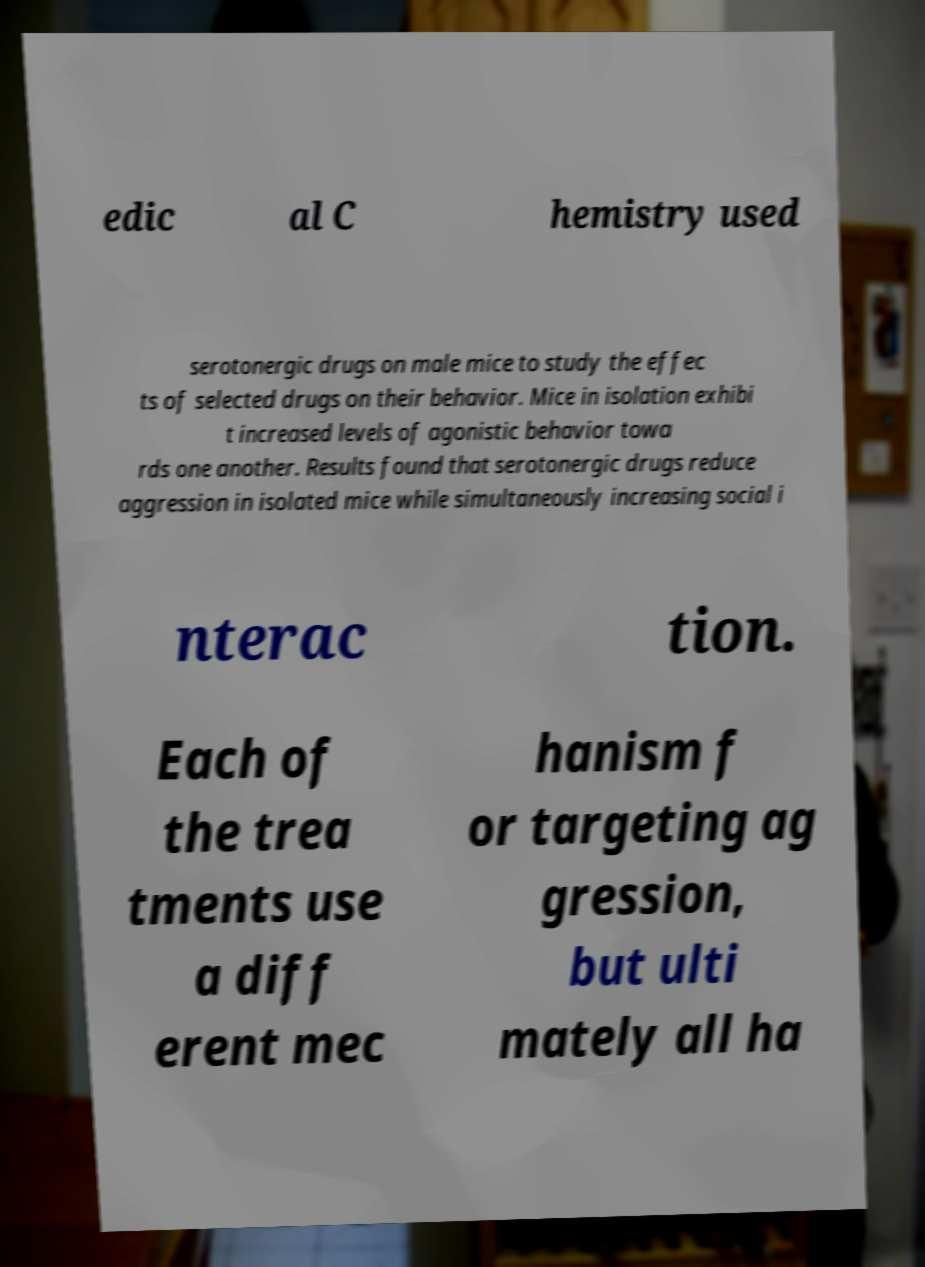What messages or text are displayed in this image? I need them in a readable, typed format. edic al C hemistry used serotonergic drugs on male mice to study the effec ts of selected drugs on their behavior. Mice in isolation exhibi t increased levels of agonistic behavior towa rds one another. Results found that serotonergic drugs reduce aggression in isolated mice while simultaneously increasing social i nterac tion. Each of the trea tments use a diff erent mec hanism f or targeting ag gression, but ulti mately all ha 